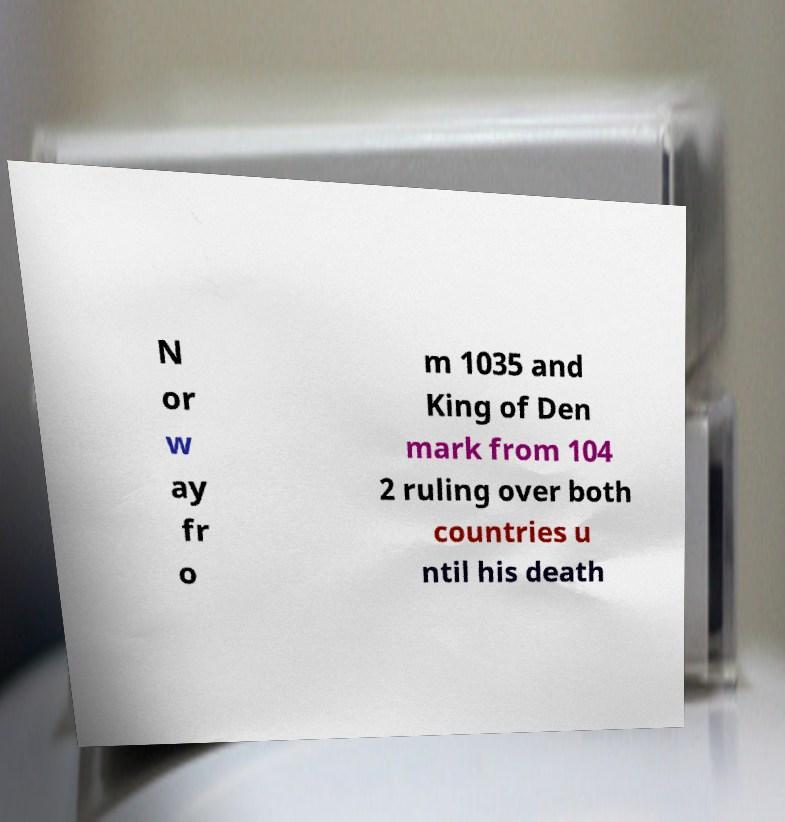What messages or text are displayed in this image? I need them in a readable, typed format. N or w ay fr o m 1035 and King of Den mark from 104 2 ruling over both countries u ntil his death 